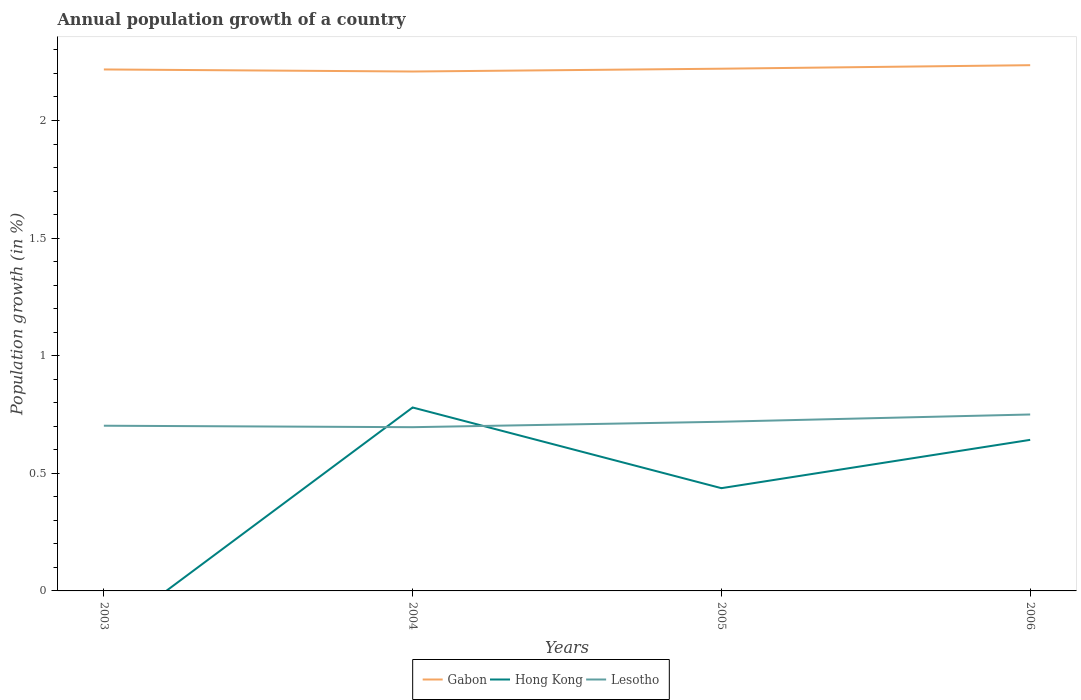How many different coloured lines are there?
Your answer should be compact. 3. Is the number of lines equal to the number of legend labels?
Provide a short and direct response. No. What is the total annual population growth in Gabon in the graph?
Your answer should be very brief. -0.01. What is the difference between the highest and the second highest annual population growth in Hong Kong?
Your answer should be compact. 0.78. Is the annual population growth in Gabon strictly greater than the annual population growth in Lesotho over the years?
Provide a succinct answer. No. What is the difference between two consecutive major ticks on the Y-axis?
Provide a succinct answer. 0.5. Does the graph contain grids?
Offer a terse response. No. Where does the legend appear in the graph?
Ensure brevity in your answer.  Bottom center. How many legend labels are there?
Your answer should be very brief. 3. What is the title of the graph?
Make the answer very short. Annual population growth of a country. Does "San Marino" appear as one of the legend labels in the graph?
Offer a terse response. No. What is the label or title of the Y-axis?
Make the answer very short. Population growth (in %). What is the Population growth (in %) in Gabon in 2003?
Your answer should be very brief. 2.22. What is the Population growth (in %) in Lesotho in 2003?
Keep it short and to the point. 0.7. What is the Population growth (in %) in Gabon in 2004?
Ensure brevity in your answer.  2.21. What is the Population growth (in %) in Hong Kong in 2004?
Provide a succinct answer. 0.78. What is the Population growth (in %) in Lesotho in 2004?
Offer a terse response. 0.7. What is the Population growth (in %) of Gabon in 2005?
Provide a succinct answer. 2.22. What is the Population growth (in %) in Hong Kong in 2005?
Provide a succinct answer. 0.44. What is the Population growth (in %) in Lesotho in 2005?
Your answer should be compact. 0.72. What is the Population growth (in %) in Gabon in 2006?
Give a very brief answer. 2.24. What is the Population growth (in %) of Hong Kong in 2006?
Offer a very short reply. 0.64. What is the Population growth (in %) in Lesotho in 2006?
Your response must be concise. 0.75. Across all years, what is the maximum Population growth (in %) of Gabon?
Provide a short and direct response. 2.24. Across all years, what is the maximum Population growth (in %) of Hong Kong?
Make the answer very short. 0.78. Across all years, what is the maximum Population growth (in %) of Lesotho?
Offer a terse response. 0.75. Across all years, what is the minimum Population growth (in %) of Gabon?
Keep it short and to the point. 2.21. Across all years, what is the minimum Population growth (in %) in Hong Kong?
Provide a short and direct response. 0. Across all years, what is the minimum Population growth (in %) in Lesotho?
Your response must be concise. 0.7. What is the total Population growth (in %) of Gabon in the graph?
Your answer should be very brief. 8.88. What is the total Population growth (in %) of Hong Kong in the graph?
Your response must be concise. 1.86. What is the total Population growth (in %) of Lesotho in the graph?
Give a very brief answer. 2.87. What is the difference between the Population growth (in %) in Gabon in 2003 and that in 2004?
Your answer should be very brief. 0.01. What is the difference between the Population growth (in %) of Lesotho in 2003 and that in 2004?
Offer a terse response. 0.01. What is the difference between the Population growth (in %) of Gabon in 2003 and that in 2005?
Your response must be concise. -0. What is the difference between the Population growth (in %) in Lesotho in 2003 and that in 2005?
Offer a terse response. -0.02. What is the difference between the Population growth (in %) of Gabon in 2003 and that in 2006?
Provide a short and direct response. -0.02. What is the difference between the Population growth (in %) of Lesotho in 2003 and that in 2006?
Keep it short and to the point. -0.05. What is the difference between the Population growth (in %) in Gabon in 2004 and that in 2005?
Offer a terse response. -0.01. What is the difference between the Population growth (in %) of Hong Kong in 2004 and that in 2005?
Your response must be concise. 0.34. What is the difference between the Population growth (in %) of Lesotho in 2004 and that in 2005?
Provide a succinct answer. -0.02. What is the difference between the Population growth (in %) of Gabon in 2004 and that in 2006?
Your response must be concise. -0.03. What is the difference between the Population growth (in %) in Hong Kong in 2004 and that in 2006?
Offer a very short reply. 0.14. What is the difference between the Population growth (in %) in Lesotho in 2004 and that in 2006?
Your answer should be compact. -0.05. What is the difference between the Population growth (in %) in Gabon in 2005 and that in 2006?
Offer a very short reply. -0.01. What is the difference between the Population growth (in %) in Hong Kong in 2005 and that in 2006?
Offer a very short reply. -0.21. What is the difference between the Population growth (in %) of Lesotho in 2005 and that in 2006?
Make the answer very short. -0.03. What is the difference between the Population growth (in %) in Gabon in 2003 and the Population growth (in %) in Hong Kong in 2004?
Give a very brief answer. 1.44. What is the difference between the Population growth (in %) in Gabon in 2003 and the Population growth (in %) in Lesotho in 2004?
Provide a succinct answer. 1.52. What is the difference between the Population growth (in %) in Gabon in 2003 and the Population growth (in %) in Hong Kong in 2005?
Your answer should be very brief. 1.78. What is the difference between the Population growth (in %) of Gabon in 2003 and the Population growth (in %) of Lesotho in 2005?
Your response must be concise. 1.5. What is the difference between the Population growth (in %) of Gabon in 2003 and the Population growth (in %) of Hong Kong in 2006?
Keep it short and to the point. 1.57. What is the difference between the Population growth (in %) in Gabon in 2003 and the Population growth (in %) in Lesotho in 2006?
Provide a succinct answer. 1.47. What is the difference between the Population growth (in %) of Gabon in 2004 and the Population growth (in %) of Hong Kong in 2005?
Keep it short and to the point. 1.77. What is the difference between the Population growth (in %) in Gabon in 2004 and the Population growth (in %) in Lesotho in 2005?
Make the answer very short. 1.49. What is the difference between the Population growth (in %) in Hong Kong in 2004 and the Population growth (in %) in Lesotho in 2005?
Your response must be concise. 0.06. What is the difference between the Population growth (in %) of Gabon in 2004 and the Population growth (in %) of Hong Kong in 2006?
Keep it short and to the point. 1.57. What is the difference between the Population growth (in %) in Gabon in 2004 and the Population growth (in %) in Lesotho in 2006?
Offer a very short reply. 1.46. What is the difference between the Population growth (in %) in Hong Kong in 2004 and the Population growth (in %) in Lesotho in 2006?
Provide a short and direct response. 0.03. What is the difference between the Population growth (in %) of Gabon in 2005 and the Population growth (in %) of Hong Kong in 2006?
Ensure brevity in your answer.  1.58. What is the difference between the Population growth (in %) of Gabon in 2005 and the Population growth (in %) of Lesotho in 2006?
Keep it short and to the point. 1.47. What is the difference between the Population growth (in %) in Hong Kong in 2005 and the Population growth (in %) in Lesotho in 2006?
Your response must be concise. -0.31. What is the average Population growth (in %) in Gabon per year?
Keep it short and to the point. 2.22. What is the average Population growth (in %) of Hong Kong per year?
Offer a terse response. 0.46. What is the average Population growth (in %) of Lesotho per year?
Keep it short and to the point. 0.72. In the year 2003, what is the difference between the Population growth (in %) of Gabon and Population growth (in %) of Lesotho?
Provide a succinct answer. 1.51. In the year 2004, what is the difference between the Population growth (in %) of Gabon and Population growth (in %) of Hong Kong?
Offer a very short reply. 1.43. In the year 2004, what is the difference between the Population growth (in %) in Gabon and Population growth (in %) in Lesotho?
Your answer should be compact. 1.51. In the year 2004, what is the difference between the Population growth (in %) of Hong Kong and Population growth (in %) of Lesotho?
Your answer should be compact. 0.08. In the year 2005, what is the difference between the Population growth (in %) in Gabon and Population growth (in %) in Hong Kong?
Keep it short and to the point. 1.78. In the year 2005, what is the difference between the Population growth (in %) of Gabon and Population growth (in %) of Lesotho?
Your answer should be compact. 1.5. In the year 2005, what is the difference between the Population growth (in %) in Hong Kong and Population growth (in %) in Lesotho?
Make the answer very short. -0.28. In the year 2006, what is the difference between the Population growth (in %) of Gabon and Population growth (in %) of Hong Kong?
Give a very brief answer. 1.59. In the year 2006, what is the difference between the Population growth (in %) in Gabon and Population growth (in %) in Lesotho?
Your answer should be very brief. 1.49. In the year 2006, what is the difference between the Population growth (in %) in Hong Kong and Population growth (in %) in Lesotho?
Provide a short and direct response. -0.11. What is the ratio of the Population growth (in %) of Lesotho in 2003 to that in 2004?
Ensure brevity in your answer.  1.01. What is the ratio of the Population growth (in %) in Gabon in 2003 to that in 2005?
Make the answer very short. 1. What is the ratio of the Population growth (in %) in Lesotho in 2003 to that in 2005?
Your response must be concise. 0.98. What is the ratio of the Population growth (in %) of Gabon in 2003 to that in 2006?
Give a very brief answer. 0.99. What is the ratio of the Population growth (in %) of Lesotho in 2003 to that in 2006?
Your answer should be very brief. 0.94. What is the ratio of the Population growth (in %) in Gabon in 2004 to that in 2005?
Your answer should be very brief. 0.99. What is the ratio of the Population growth (in %) in Hong Kong in 2004 to that in 2005?
Offer a terse response. 1.79. What is the ratio of the Population growth (in %) of Lesotho in 2004 to that in 2005?
Provide a succinct answer. 0.97. What is the ratio of the Population growth (in %) in Gabon in 2004 to that in 2006?
Make the answer very short. 0.99. What is the ratio of the Population growth (in %) in Hong Kong in 2004 to that in 2006?
Make the answer very short. 1.21. What is the ratio of the Population growth (in %) in Lesotho in 2004 to that in 2006?
Offer a very short reply. 0.93. What is the ratio of the Population growth (in %) in Gabon in 2005 to that in 2006?
Give a very brief answer. 0.99. What is the ratio of the Population growth (in %) in Hong Kong in 2005 to that in 2006?
Offer a very short reply. 0.68. What is the ratio of the Population growth (in %) of Lesotho in 2005 to that in 2006?
Your answer should be compact. 0.96. What is the difference between the highest and the second highest Population growth (in %) of Gabon?
Provide a short and direct response. 0.01. What is the difference between the highest and the second highest Population growth (in %) of Hong Kong?
Offer a terse response. 0.14. What is the difference between the highest and the second highest Population growth (in %) in Lesotho?
Your answer should be very brief. 0.03. What is the difference between the highest and the lowest Population growth (in %) of Gabon?
Keep it short and to the point. 0.03. What is the difference between the highest and the lowest Population growth (in %) in Hong Kong?
Offer a terse response. 0.78. What is the difference between the highest and the lowest Population growth (in %) of Lesotho?
Provide a succinct answer. 0.05. 